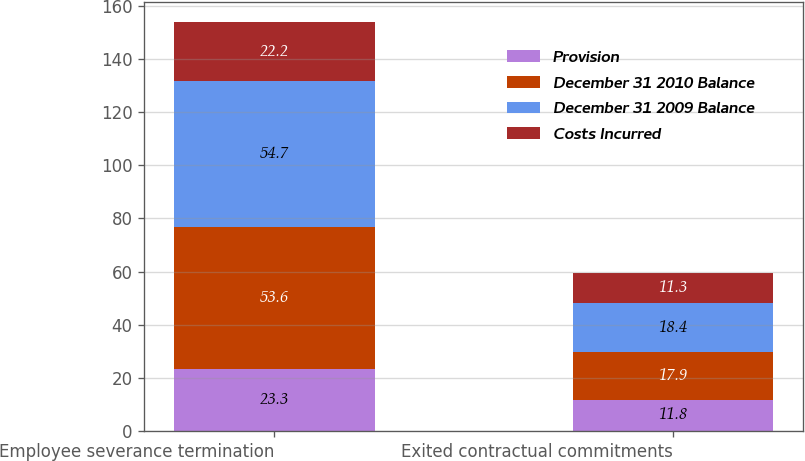Convert chart to OTSL. <chart><loc_0><loc_0><loc_500><loc_500><stacked_bar_chart><ecel><fcel>Employee severance termination<fcel>Exited contractual commitments<nl><fcel>Provision<fcel>23.3<fcel>11.8<nl><fcel>December 31 2010 Balance<fcel>53.6<fcel>17.9<nl><fcel>December 31 2009 Balance<fcel>54.7<fcel>18.4<nl><fcel>Costs Incurred<fcel>22.2<fcel>11.3<nl></chart> 